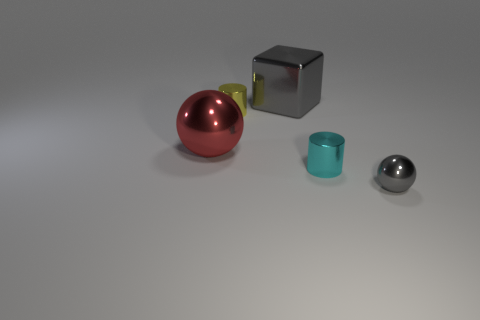Add 3 big brown rubber balls. How many objects exist? 8 Subtract all cylinders. How many objects are left? 3 Add 5 small yellow things. How many small yellow things are left? 6 Add 5 shiny balls. How many shiny balls exist? 7 Subtract 0 purple cubes. How many objects are left? 5 Subtract all tiny gray things. Subtract all gray shiny things. How many objects are left? 2 